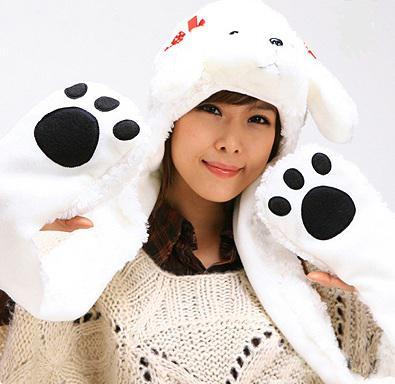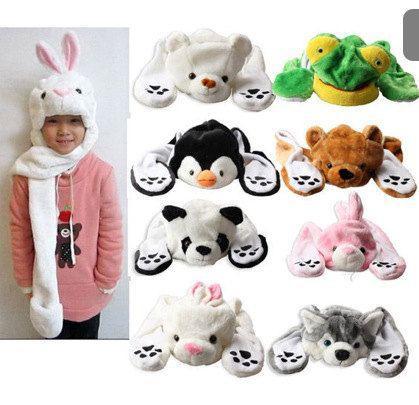The first image is the image on the left, the second image is the image on the right. Assess this claim about the two images: "A young Asian woman in a pale knit top is holding at least one paw-decorated mitten up to the camera.". Correct or not? Answer yes or no. Yes. 